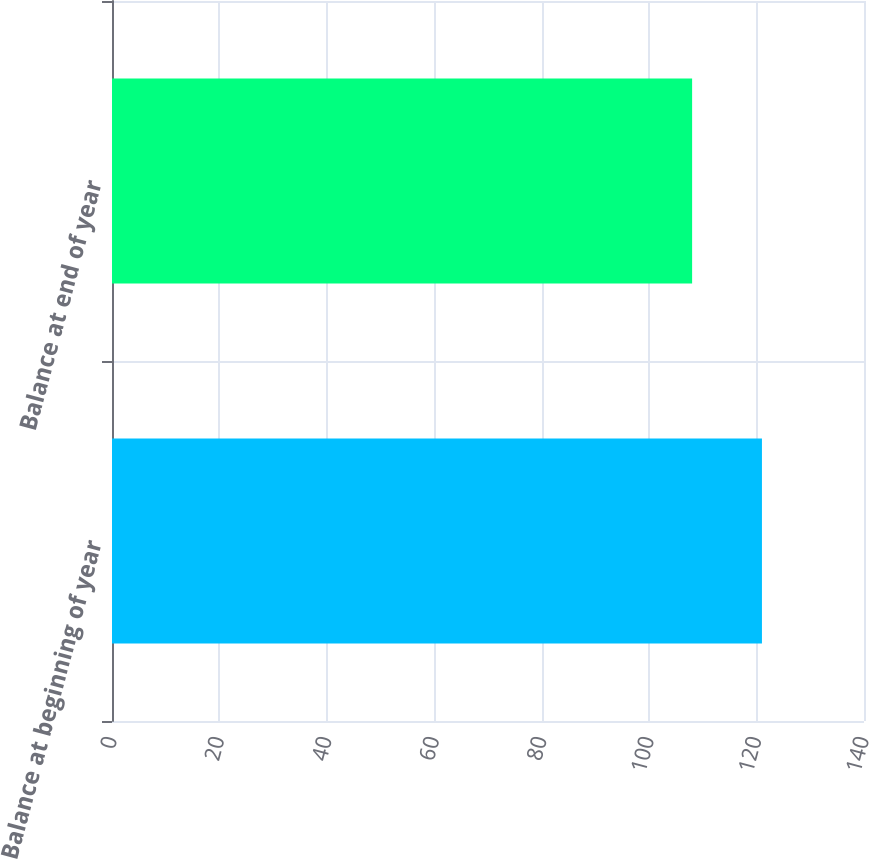Convert chart. <chart><loc_0><loc_0><loc_500><loc_500><bar_chart><fcel>Balance at beginning of year<fcel>Balance at end of year<nl><fcel>121<fcel>108<nl></chart> 